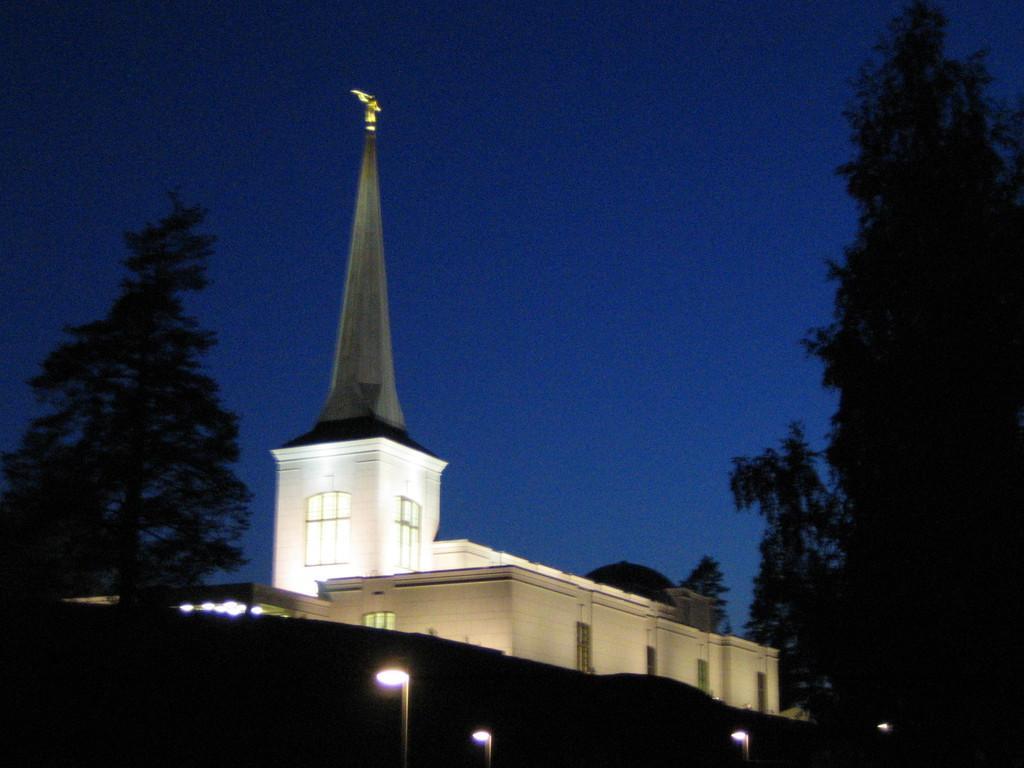Please provide a concise description of this image. In this picture we can see few trees, lights and a building. 